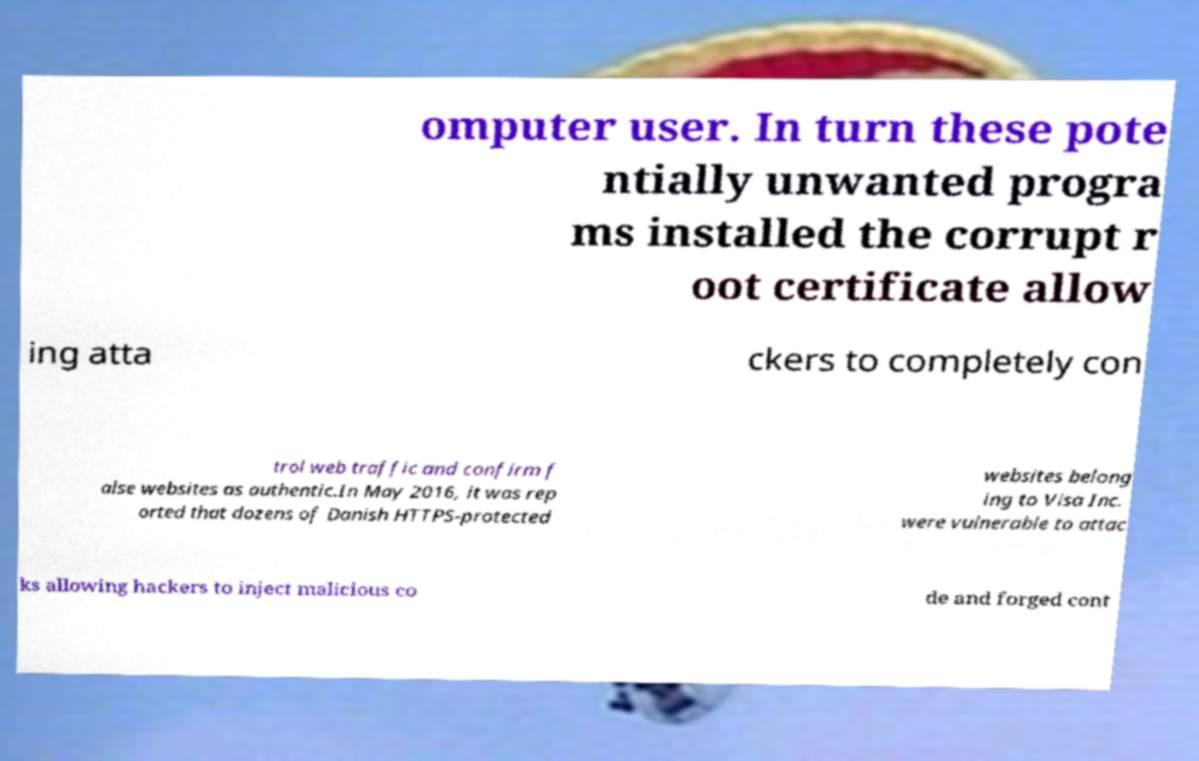Could you extract and type out the text from this image? omputer user. In turn these pote ntially unwanted progra ms installed the corrupt r oot certificate allow ing atta ckers to completely con trol web traffic and confirm f alse websites as authentic.In May 2016, it was rep orted that dozens of Danish HTTPS-protected websites belong ing to Visa Inc. were vulnerable to attac ks allowing hackers to inject malicious co de and forged cont 